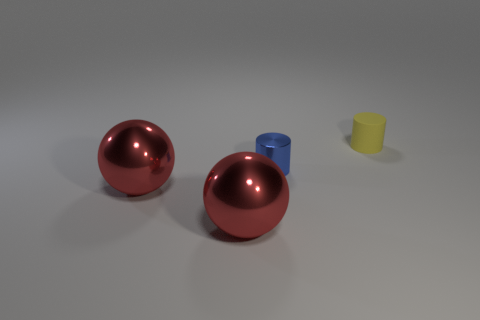Add 4 big red things. How many objects exist? 8 Add 4 small blue cylinders. How many small blue cylinders are left? 5 Add 3 yellow things. How many yellow things exist? 4 Subtract 0 cyan cylinders. How many objects are left? 4 Subtract all brown matte spheres. Subtract all large red metallic objects. How many objects are left? 2 